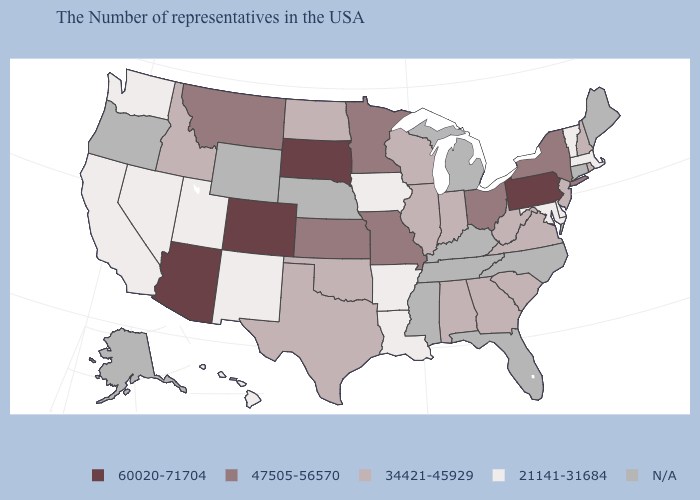Which states have the lowest value in the Northeast?
Give a very brief answer. Massachusetts, Vermont. What is the value of North Dakota?
Write a very short answer. 34421-45929. What is the value of Wisconsin?
Write a very short answer. 34421-45929. What is the value of Rhode Island?
Write a very short answer. 34421-45929. Does North Dakota have the lowest value in the MidWest?
Concise answer only. No. What is the value of West Virginia?
Short answer required. 34421-45929. Among the states that border Iowa , which have the lowest value?
Be succinct. Wisconsin, Illinois. Name the states that have a value in the range 60020-71704?
Short answer required. Pennsylvania, South Dakota, Colorado, Arizona. What is the value of Connecticut?
Be succinct. N/A. What is the value of New Mexico?
Give a very brief answer. 21141-31684. Does New York have the lowest value in the USA?
Keep it brief. No. Name the states that have a value in the range 21141-31684?
Quick response, please. Massachusetts, Vermont, Delaware, Maryland, Louisiana, Arkansas, Iowa, New Mexico, Utah, Nevada, California, Washington, Hawaii. Which states hav the highest value in the MidWest?
Quick response, please. South Dakota. 